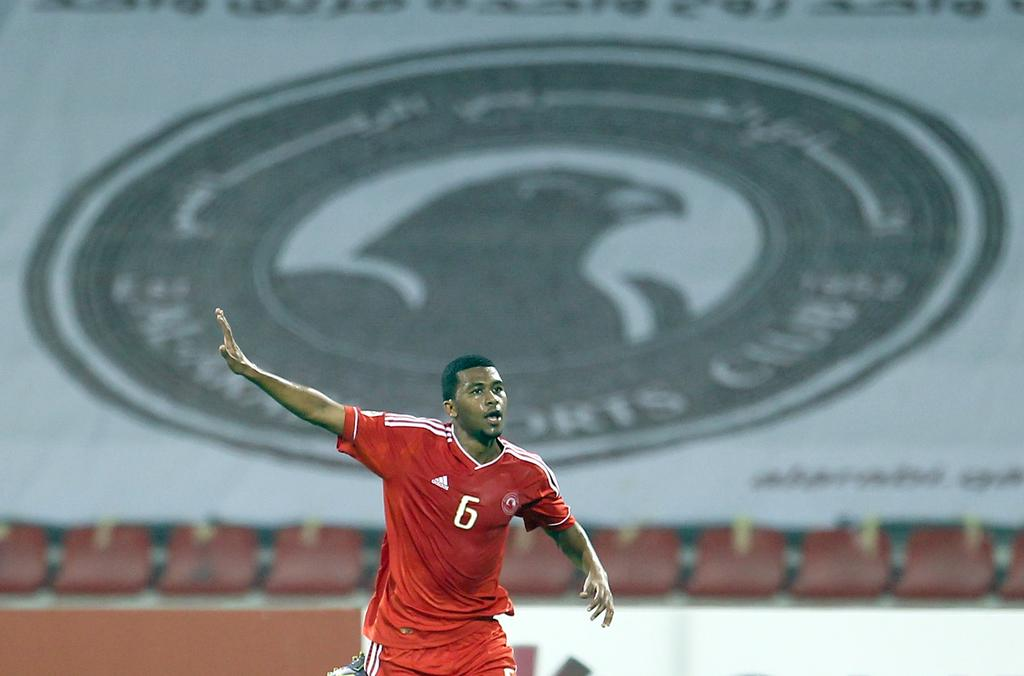Provide a one-sentence caption for the provided image. A large banner displaying a bird and the words SPORTS CLUB hangs in the background as a soccer player points. 